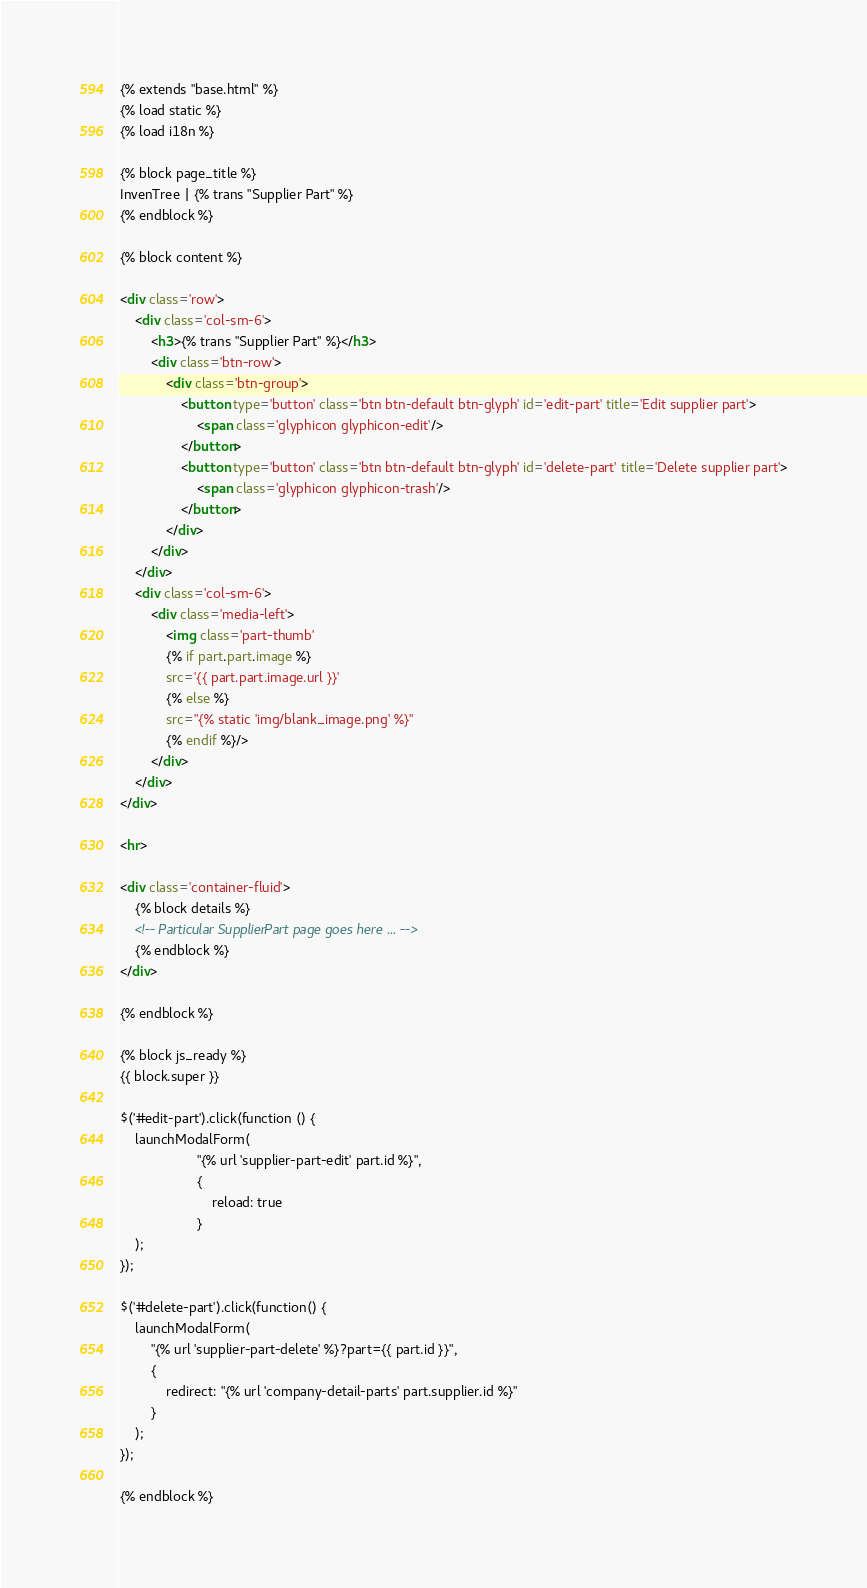Convert code to text. <code><loc_0><loc_0><loc_500><loc_500><_HTML_>{% extends "base.html" %}
{% load static %}
{% load i18n %}

{% block page_title %}
InvenTree | {% trans "Supplier Part" %}
{% endblock %}

{% block content %}

<div class='row'>
    <div class='col-sm-6'>
        <h3>{% trans "Supplier Part" %}</h3>
        <div class='btn-row'>
            <div class='btn-group'>
                <button type='button' class='btn btn-default btn-glyph' id='edit-part' title='Edit supplier part'>
                    <span class='glyphicon glyphicon-edit'/>
                </button>
                <button type='button' class='btn btn-default btn-glyph' id='delete-part' title='Delete supplier part'>
                    <span class='glyphicon glyphicon-trash'/>
                </button>
            </div>
        </div>
    </div>
    <div class='col-sm-6'>
        <div class='media-left'>
            <img class='part-thumb'
            {% if part.part.image %}
            src='{{ part.part.image.url }}'
            {% else %}
            src="{% static 'img/blank_image.png' %}"
            {% endif %}/>
        </div>
    </div>
</div>

<hr>

<div class='container-fluid'>
    {% block details %}
    <!-- Particular SupplierPart page goes here ... -->
    {% endblock %}
</div>

{% endblock %}

{% block js_ready %}
{{ block.super }}

$('#edit-part').click(function () {
    launchModalForm(
                    "{% url 'supplier-part-edit' part.id %}",
                    {
                        reload: true
                    }
    );
});

$('#delete-part').click(function() {
    launchModalForm(
        "{% url 'supplier-part-delete' %}?part={{ part.id }}",
        {
            redirect: "{% url 'company-detail-parts' part.supplier.id %}"
        }
    );
});

{% endblock %}</code> 